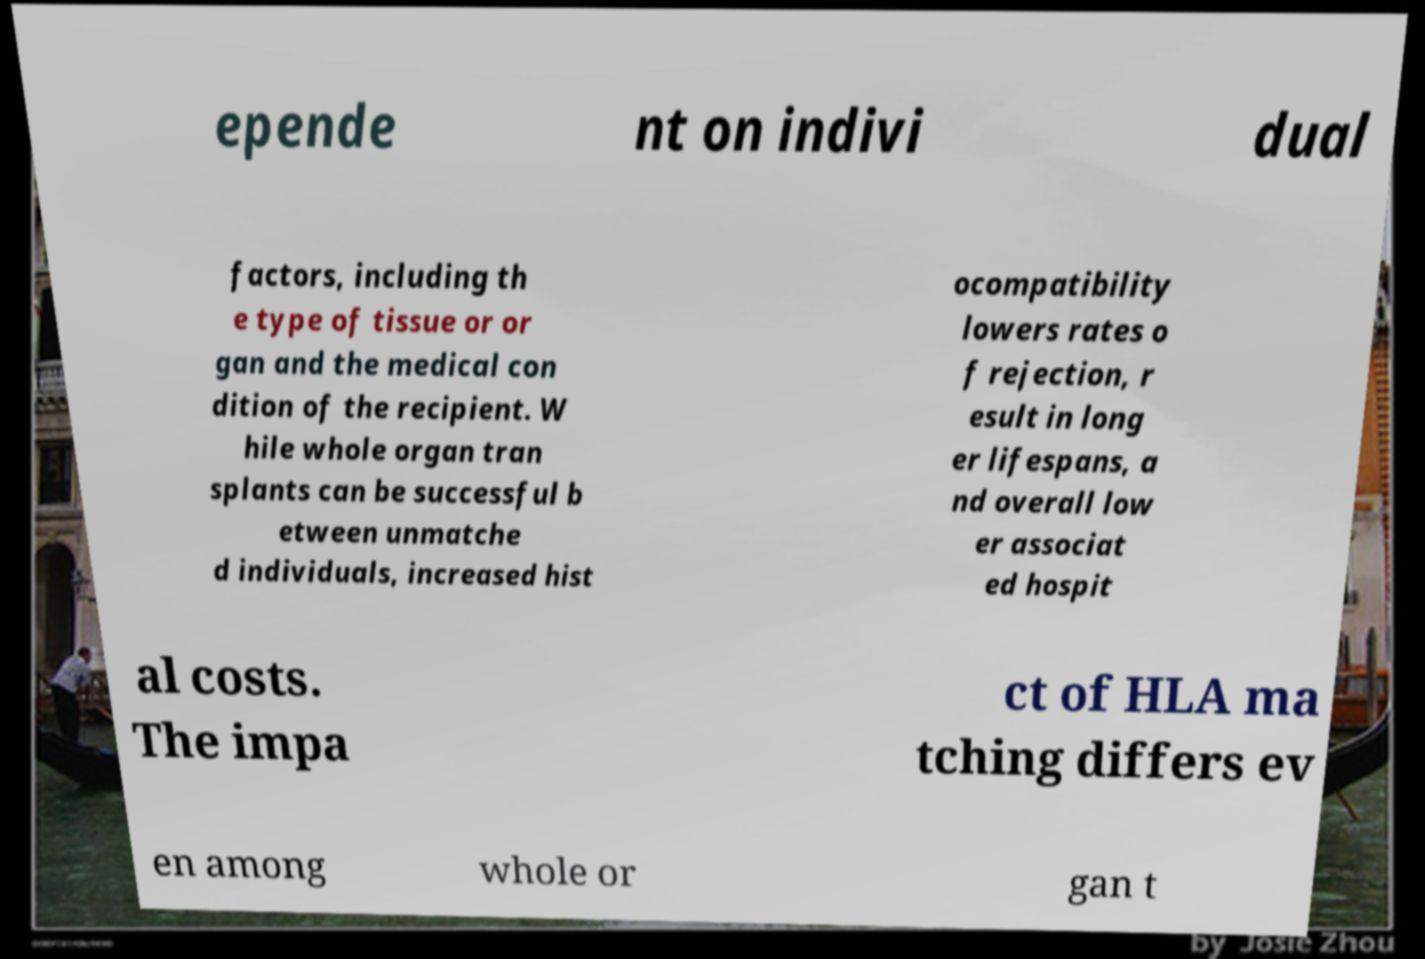For documentation purposes, I need the text within this image transcribed. Could you provide that? epende nt on indivi dual factors, including th e type of tissue or or gan and the medical con dition of the recipient. W hile whole organ tran splants can be successful b etween unmatche d individuals, increased hist ocompatibility lowers rates o f rejection, r esult in long er lifespans, a nd overall low er associat ed hospit al costs. The impa ct of HLA ma tching differs ev en among whole or gan t 